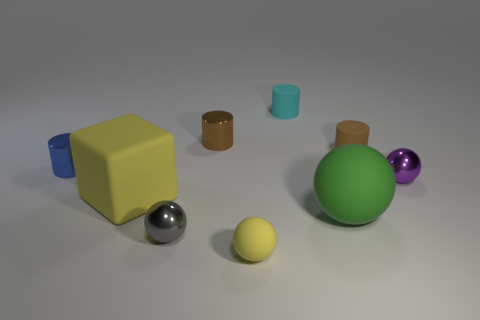There is a big green thing that is the same shape as the small gray shiny object; what is it made of?
Offer a terse response. Rubber. Is the number of large yellow rubber things to the right of the yellow matte block the same as the number of small yellow spheres behind the green matte object?
Give a very brief answer. Yes. What shape is the tiny thing that is the same color as the block?
Offer a terse response. Sphere. There is a large object that is on the left side of the green thing; what is it made of?
Your response must be concise. Rubber. Is the size of the purple shiny ball the same as the green rubber sphere?
Offer a terse response. No. Is the number of small spheres behind the brown rubber thing greater than the number of tiny brown shiny objects?
Offer a terse response. No. What is the size of the cyan thing that is the same material as the big sphere?
Offer a terse response. Small. There is a cyan rubber cylinder; are there any tiny purple spheres on the left side of it?
Give a very brief answer. No. Do the small yellow object and the gray thing have the same shape?
Ensure brevity in your answer.  Yes. There is a shiny object in front of the tiny object that is right of the brown thing that is on the right side of the small yellow rubber sphere; what size is it?
Keep it short and to the point. Small. 